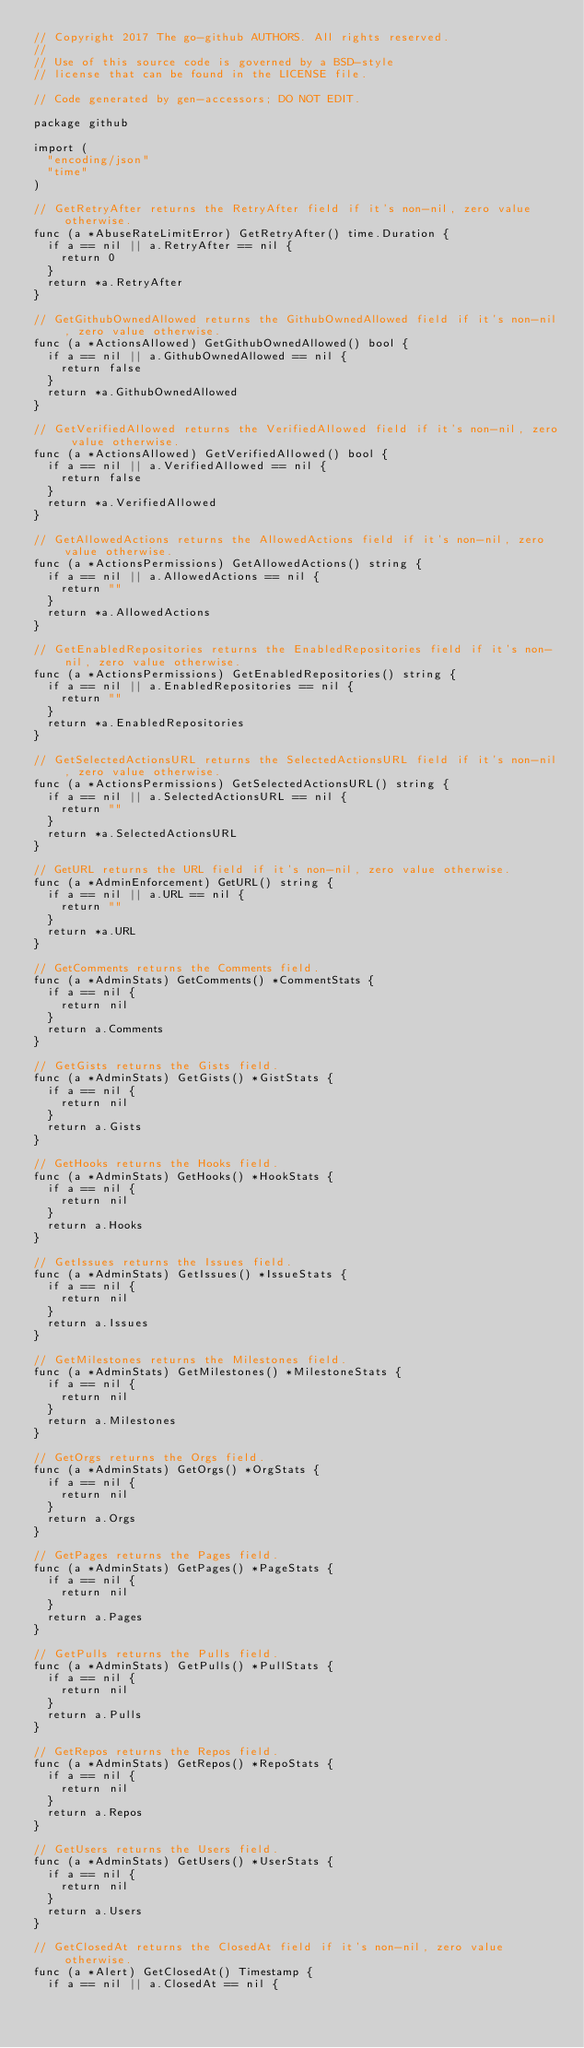<code> <loc_0><loc_0><loc_500><loc_500><_Go_>// Copyright 2017 The go-github AUTHORS. All rights reserved.
//
// Use of this source code is governed by a BSD-style
// license that can be found in the LICENSE file.

// Code generated by gen-accessors; DO NOT EDIT.

package github

import (
	"encoding/json"
	"time"
)

// GetRetryAfter returns the RetryAfter field if it's non-nil, zero value otherwise.
func (a *AbuseRateLimitError) GetRetryAfter() time.Duration {
	if a == nil || a.RetryAfter == nil {
		return 0
	}
	return *a.RetryAfter
}

// GetGithubOwnedAllowed returns the GithubOwnedAllowed field if it's non-nil, zero value otherwise.
func (a *ActionsAllowed) GetGithubOwnedAllowed() bool {
	if a == nil || a.GithubOwnedAllowed == nil {
		return false
	}
	return *a.GithubOwnedAllowed
}

// GetVerifiedAllowed returns the VerifiedAllowed field if it's non-nil, zero value otherwise.
func (a *ActionsAllowed) GetVerifiedAllowed() bool {
	if a == nil || a.VerifiedAllowed == nil {
		return false
	}
	return *a.VerifiedAllowed
}

// GetAllowedActions returns the AllowedActions field if it's non-nil, zero value otherwise.
func (a *ActionsPermissions) GetAllowedActions() string {
	if a == nil || a.AllowedActions == nil {
		return ""
	}
	return *a.AllowedActions
}

// GetEnabledRepositories returns the EnabledRepositories field if it's non-nil, zero value otherwise.
func (a *ActionsPermissions) GetEnabledRepositories() string {
	if a == nil || a.EnabledRepositories == nil {
		return ""
	}
	return *a.EnabledRepositories
}

// GetSelectedActionsURL returns the SelectedActionsURL field if it's non-nil, zero value otherwise.
func (a *ActionsPermissions) GetSelectedActionsURL() string {
	if a == nil || a.SelectedActionsURL == nil {
		return ""
	}
	return *a.SelectedActionsURL
}

// GetURL returns the URL field if it's non-nil, zero value otherwise.
func (a *AdminEnforcement) GetURL() string {
	if a == nil || a.URL == nil {
		return ""
	}
	return *a.URL
}

// GetComments returns the Comments field.
func (a *AdminStats) GetComments() *CommentStats {
	if a == nil {
		return nil
	}
	return a.Comments
}

// GetGists returns the Gists field.
func (a *AdminStats) GetGists() *GistStats {
	if a == nil {
		return nil
	}
	return a.Gists
}

// GetHooks returns the Hooks field.
func (a *AdminStats) GetHooks() *HookStats {
	if a == nil {
		return nil
	}
	return a.Hooks
}

// GetIssues returns the Issues field.
func (a *AdminStats) GetIssues() *IssueStats {
	if a == nil {
		return nil
	}
	return a.Issues
}

// GetMilestones returns the Milestones field.
func (a *AdminStats) GetMilestones() *MilestoneStats {
	if a == nil {
		return nil
	}
	return a.Milestones
}

// GetOrgs returns the Orgs field.
func (a *AdminStats) GetOrgs() *OrgStats {
	if a == nil {
		return nil
	}
	return a.Orgs
}

// GetPages returns the Pages field.
func (a *AdminStats) GetPages() *PageStats {
	if a == nil {
		return nil
	}
	return a.Pages
}

// GetPulls returns the Pulls field.
func (a *AdminStats) GetPulls() *PullStats {
	if a == nil {
		return nil
	}
	return a.Pulls
}

// GetRepos returns the Repos field.
func (a *AdminStats) GetRepos() *RepoStats {
	if a == nil {
		return nil
	}
	return a.Repos
}

// GetUsers returns the Users field.
func (a *AdminStats) GetUsers() *UserStats {
	if a == nil {
		return nil
	}
	return a.Users
}

// GetClosedAt returns the ClosedAt field if it's non-nil, zero value otherwise.
func (a *Alert) GetClosedAt() Timestamp {
	if a == nil || a.ClosedAt == nil {</code> 